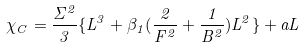Convert formula to latex. <formula><loc_0><loc_0><loc_500><loc_500>\chi _ { C } = \frac { \Sigma ^ { 2 } } { 3 } \{ L ^ { 3 } + \beta _ { 1 } ( \frac { 2 } { F ^ { 2 } } + \frac { 1 } { B ^ { 2 } } ) L ^ { 2 } \} + a L</formula> 